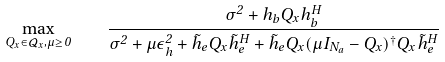Convert formula to latex. <formula><loc_0><loc_0><loc_500><loc_500>\max _ { Q _ { x } \in \mathcal { Q } _ { x } , \mu \geq 0 } \quad \frac { \sigma ^ { 2 } + h _ { b } Q _ { x } h _ { b } ^ { H } } { \sigma ^ { 2 } + \mu \epsilon _ { h } ^ { 2 } + \tilde { h } _ { e } Q _ { x } \tilde { h } _ { e } ^ { H } + \tilde { h } _ { e } Q _ { x } ( \mu I _ { N _ { a } } - Q _ { x } ) ^ { \dag } Q _ { x } \tilde { h } _ { e } ^ { H } }</formula> 